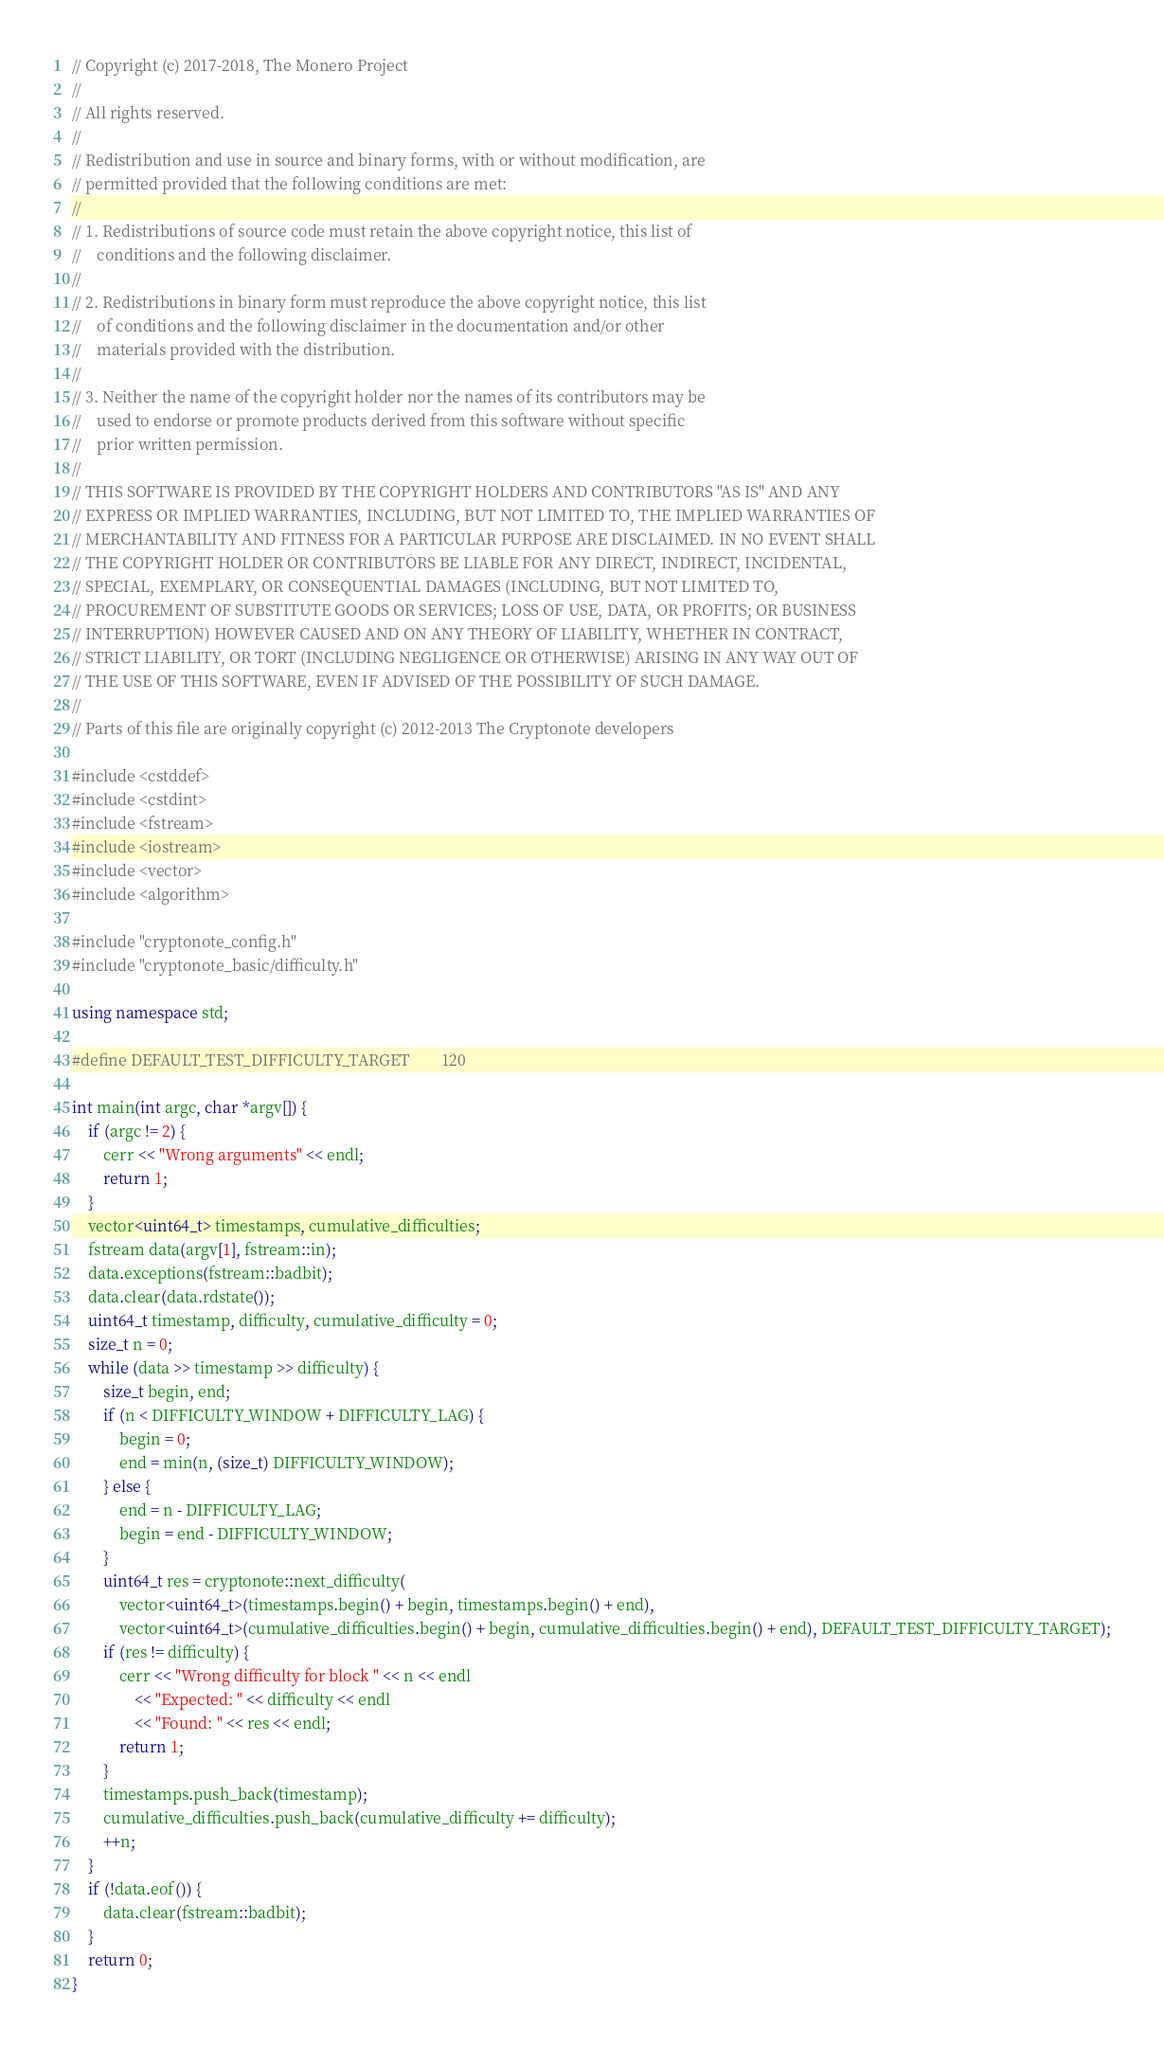<code> <loc_0><loc_0><loc_500><loc_500><_C++_>// Copyright (c) 2017-2018, The Monero Project
// 
// All rights reserved.
// 
// Redistribution and use in source and binary forms, with or without modification, are
// permitted provided that the following conditions are met:
// 
// 1. Redistributions of source code must retain the above copyright notice, this list of
//    conditions and the following disclaimer.
// 
// 2. Redistributions in binary form must reproduce the above copyright notice, this list
//    of conditions and the following disclaimer in the documentation and/or other
//    materials provided with the distribution.
// 
// 3. Neither the name of the copyright holder nor the names of its contributors may be
//    used to endorse or promote products derived from this software without specific
//    prior written permission.
// 
// THIS SOFTWARE IS PROVIDED BY THE COPYRIGHT HOLDERS AND CONTRIBUTORS "AS IS" AND ANY
// EXPRESS OR IMPLIED WARRANTIES, INCLUDING, BUT NOT LIMITED TO, THE IMPLIED WARRANTIES OF
// MERCHANTABILITY AND FITNESS FOR A PARTICULAR PURPOSE ARE DISCLAIMED. IN NO EVENT SHALL
// THE COPYRIGHT HOLDER OR CONTRIBUTORS BE LIABLE FOR ANY DIRECT, INDIRECT, INCIDENTAL,
// SPECIAL, EXEMPLARY, OR CONSEQUENTIAL DAMAGES (INCLUDING, BUT NOT LIMITED TO,
// PROCUREMENT OF SUBSTITUTE GOODS OR SERVICES; LOSS OF USE, DATA, OR PROFITS; OR BUSINESS
// INTERRUPTION) HOWEVER CAUSED AND ON ANY THEORY OF LIABILITY, WHETHER IN CONTRACT,
// STRICT LIABILITY, OR TORT (INCLUDING NEGLIGENCE OR OTHERWISE) ARISING IN ANY WAY OUT OF
// THE USE OF THIS SOFTWARE, EVEN IF ADVISED OF THE POSSIBILITY OF SUCH DAMAGE.
// 
// Parts of this file are originally copyright (c) 2012-2013 The Cryptonote developers

#include <cstddef>
#include <cstdint>
#include <fstream>
#include <iostream>
#include <vector>
#include <algorithm>

#include "cryptonote_config.h"
#include "cryptonote_basic/difficulty.h"

using namespace std;

#define DEFAULT_TEST_DIFFICULTY_TARGET        120

int main(int argc, char *argv[]) {
    if (argc != 2) {
        cerr << "Wrong arguments" << endl;
        return 1;
    }
    vector<uint64_t> timestamps, cumulative_difficulties;
    fstream data(argv[1], fstream::in);
    data.exceptions(fstream::badbit);
    data.clear(data.rdstate());
    uint64_t timestamp, difficulty, cumulative_difficulty = 0;
    size_t n = 0;
    while (data >> timestamp >> difficulty) {
        size_t begin, end;
        if (n < DIFFICULTY_WINDOW + DIFFICULTY_LAG) {
            begin = 0;
            end = min(n, (size_t) DIFFICULTY_WINDOW);
        } else {
            end = n - DIFFICULTY_LAG;
            begin = end - DIFFICULTY_WINDOW;
        }
        uint64_t res = cryptonote::next_difficulty(
            vector<uint64_t>(timestamps.begin() + begin, timestamps.begin() + end),
            vector<uint64_t>(cumulative_difficulties.begin() + begin, cumulative_difficulties.begin() + end), DEFAULT_TEST_DIFFICULTY_TARGET);
        if (res != difficulty) {
            cerr << "Wrong difficulty for block " << n << endl
                << "Expected: " << difficulty << endl
                << "Found: " << res << endl;
            return 1;
        }
        timestamps.push_back(timestamp);
        cumulative_difficulties.push_back(cumulative_difficulty += difficulty);
        ++n;
    }
    if (!data.eof()) {
        data.clear(fstream::badbit);
    }
    return 0;
}
</code> 